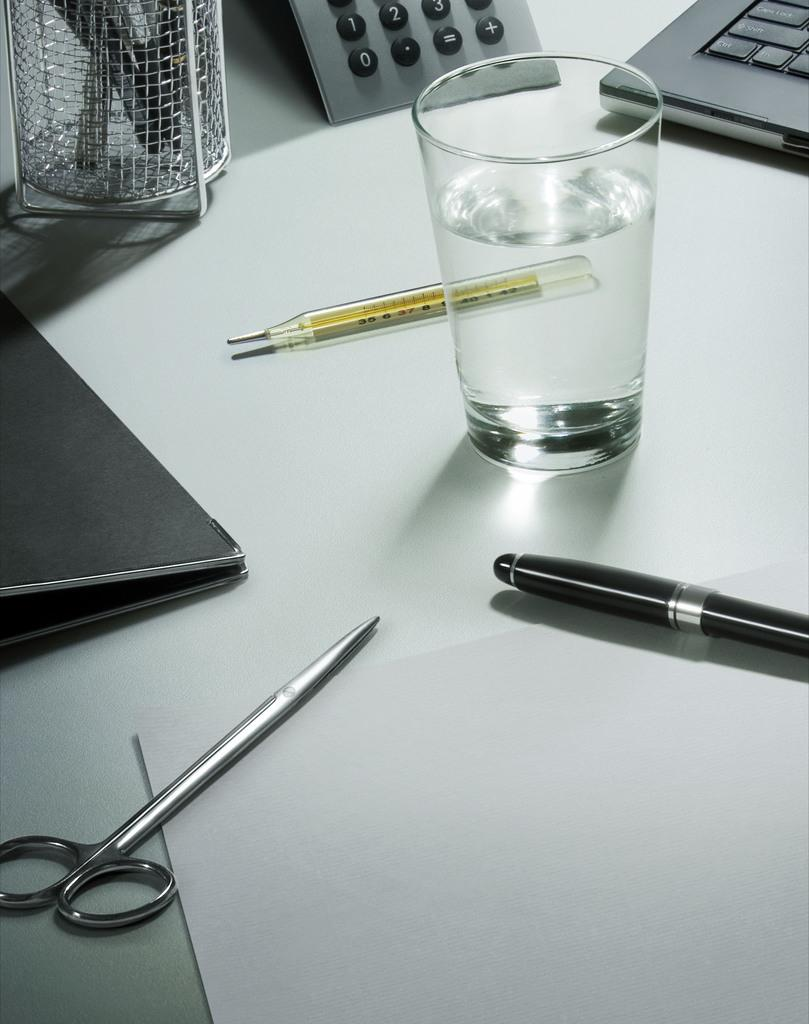What type of tool is present in the image? There are scissors in the image. What device is used for measuring temperature in the image? There is a mercury thermometer in the image. What is the container for holding pens in the image? There is a pen stand with pens in the image. What device is used for performing calculations in the image? There is a calculator in the image. What writing instrument is present in the image? There is a pen in the image. What is used for writing or drawing in the image? There is paper in the image. What is the container for holding water in the image? There is a glass with water in the image. What other objects are present on a white platform in the image? There are other objects on a white platform in the image, but their specific details are not mentioned in the provided facts. What type of science experiment is being conducted in the image? There is no indication of a science experiment being conducted in the image. How many people are present in the image, and what are they doing? The number of people present in the image is not mentioned in the provided facts, and their actions are not described. 